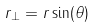Convert formula to latex. <formula><loc_0><loc_0><loc_500><loc_500>r _ { \perp } = r \sin ( \theta )</formula> 